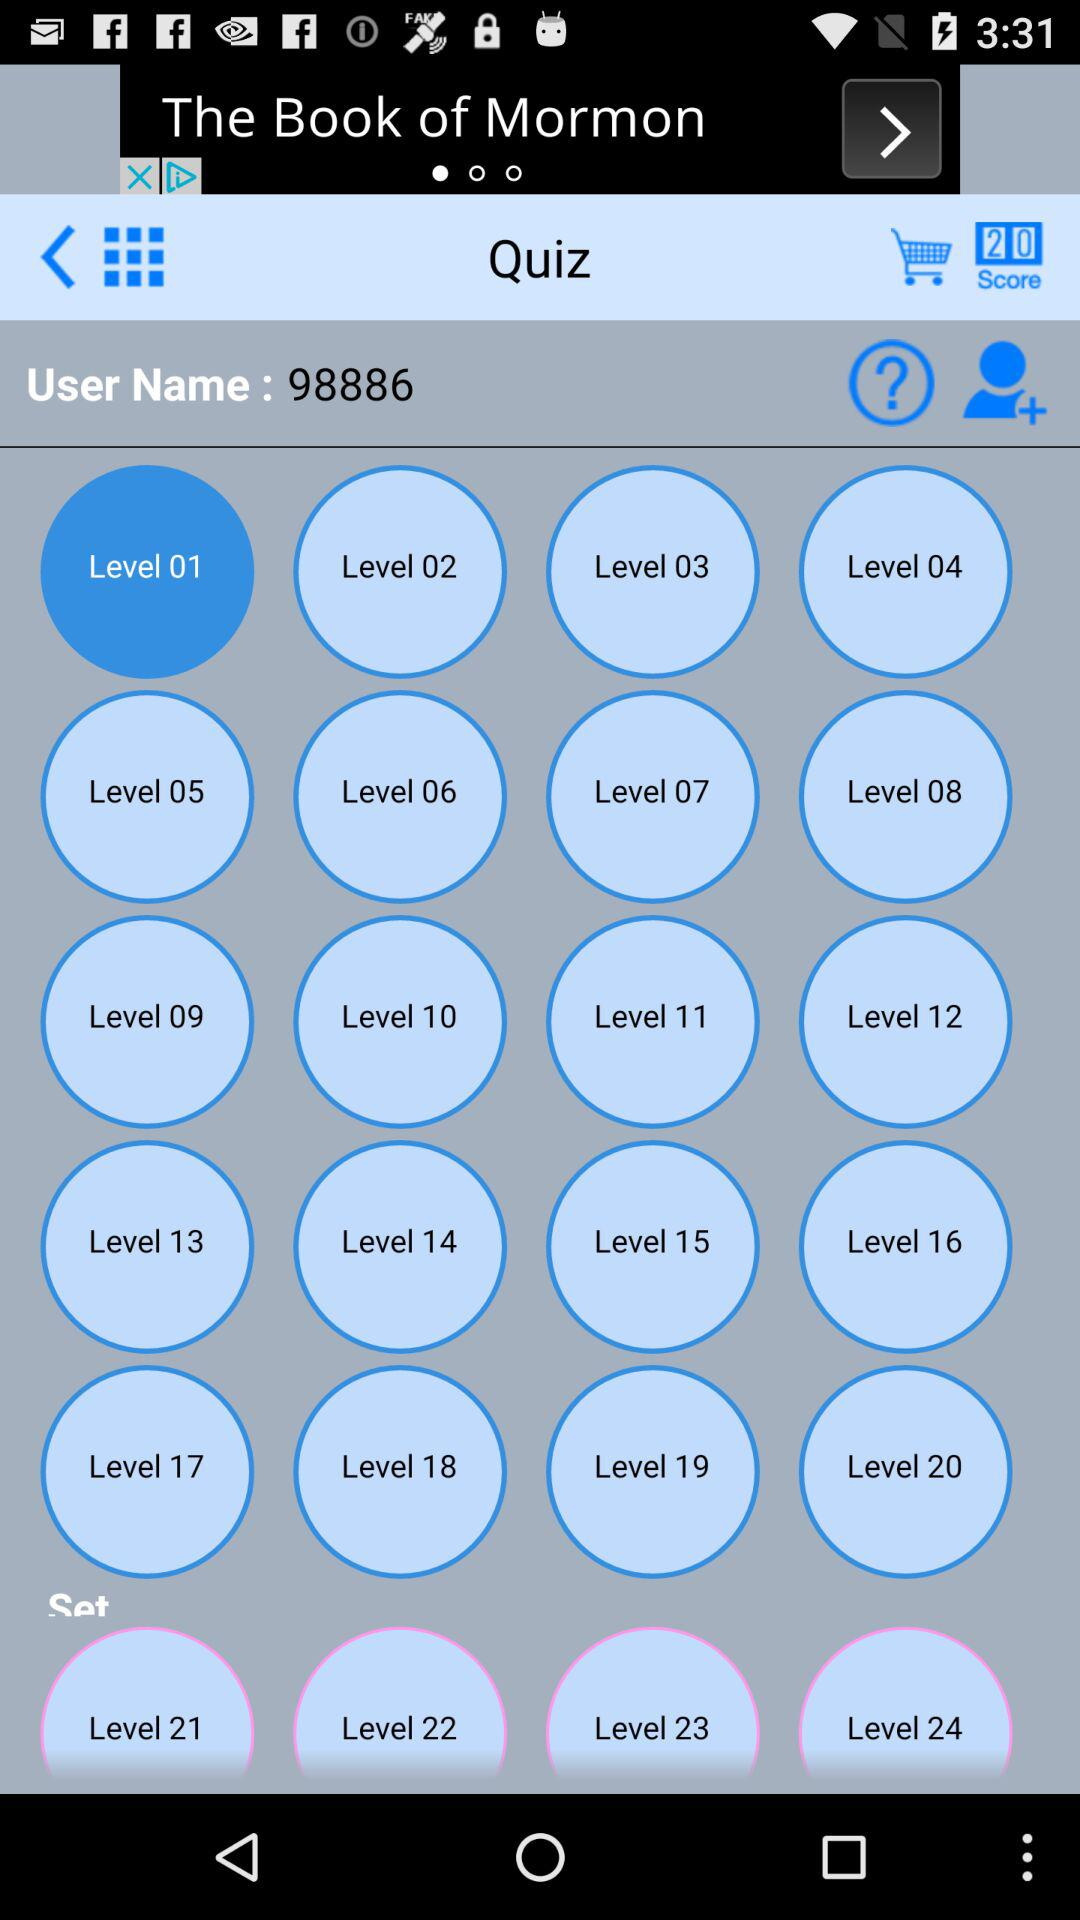What is the score? The score is 20. 